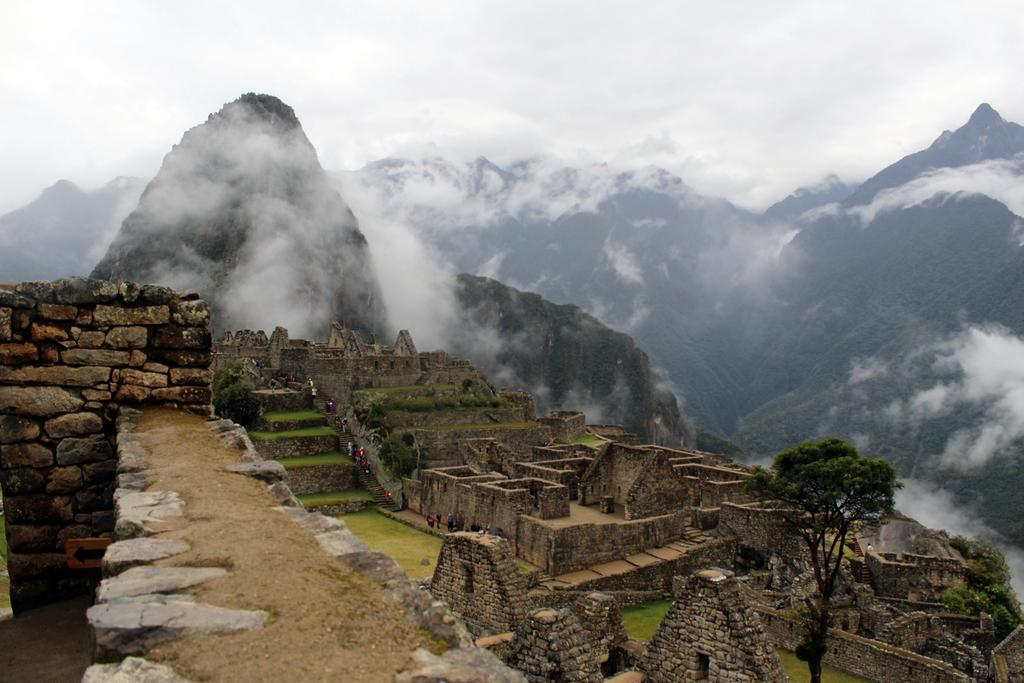What type of structures can be seen in the image? There are forts in the image. What type of vegetation is present in the image? There is grass and trees in the image. Are there any people visible in the image? Yes, there are people in the image. What type of architectural features can be seen in the image? There are walls in the image. What additional object can be seen in the image? There is a sign board in the image. What can be seen in the background of the image? There are mountains, fog, and sky visible in the background of the image. How many bells can be heard ringing in the image? There are no bells present in the image, so it is not possible to hear them ringing. What type of sheet is covering the forts in the image? There is no sheet covering the forts in the image; they are visible and not obstructed. 